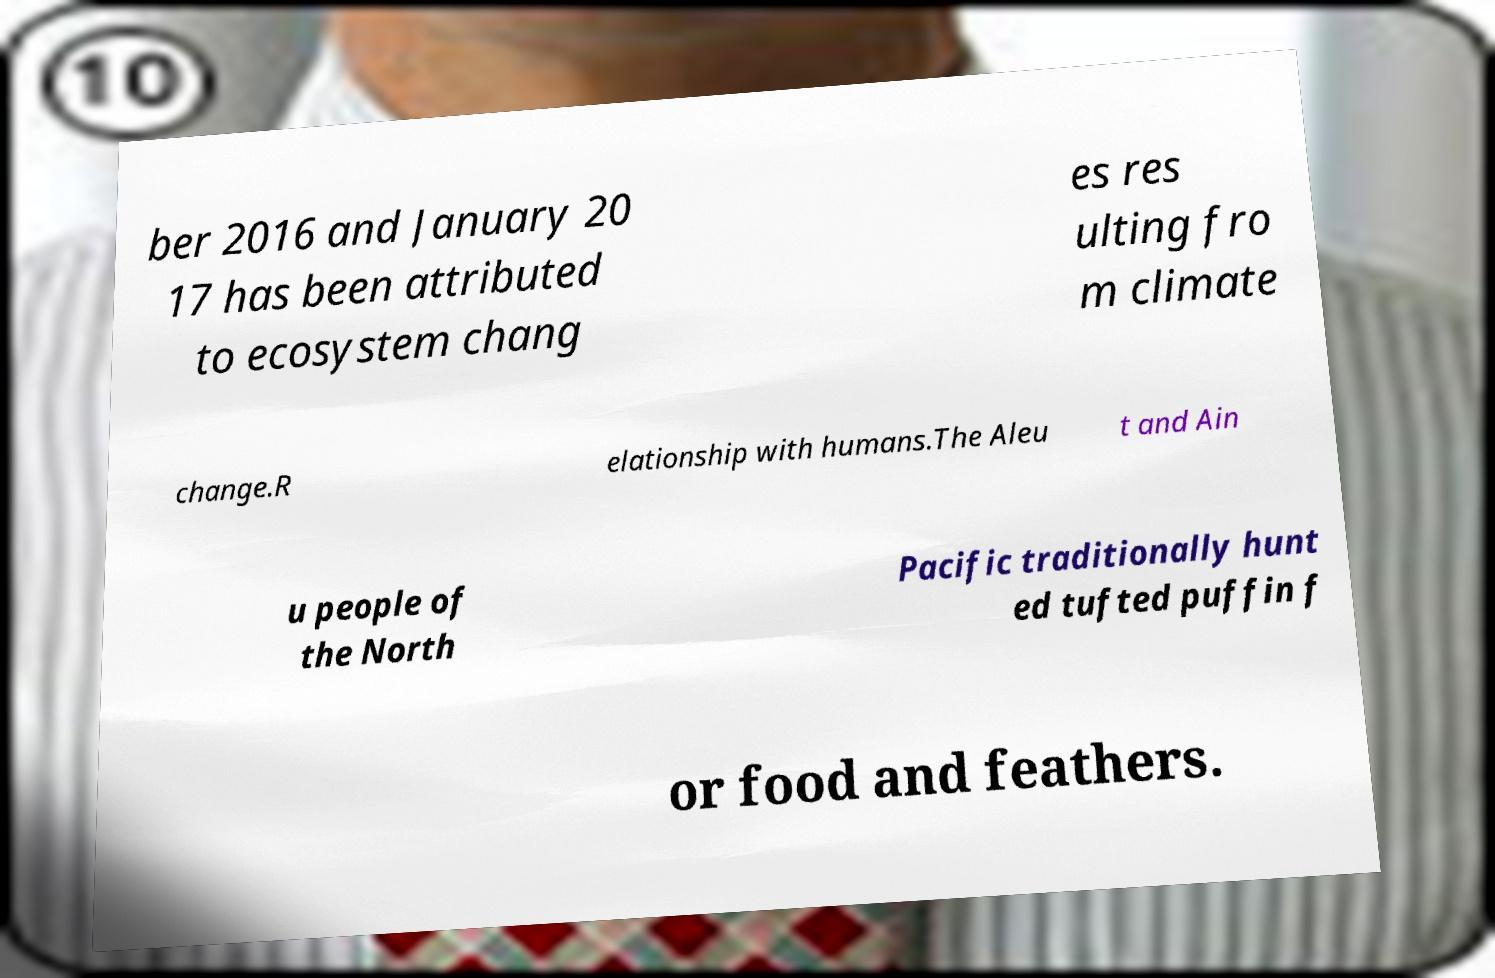Please identify and transcribe the text found in this image. ber 2016 and January 20 17 has been attributed to ecosystem chang es res ulting fro m climate change.R elationship with humans.The Aleu t and Ain u people of the North Pacific traditionally hunt ed tufted puffin f or food and feathers. 